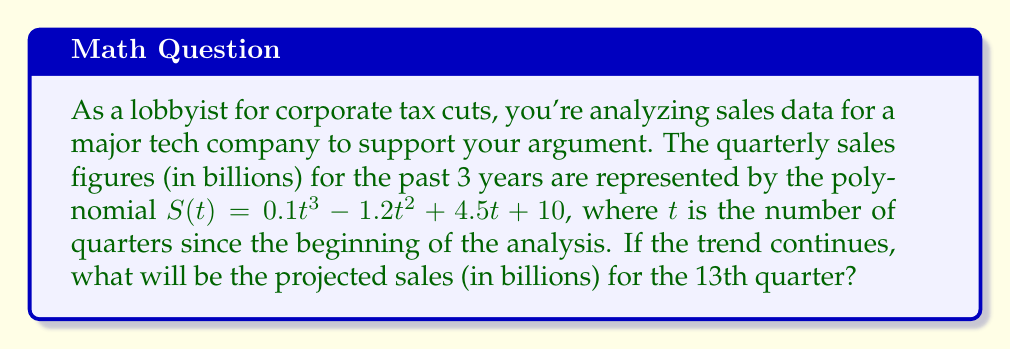Provide a solution to this math problem. To solve this problem, we need to follow these steps:

1) We're given the polynomial function for sales:
   $S(t) = 0.1t^3 - 1.2t^2 + 4.5t + 10$

2) We need to find $S(13)$, as the 13th quarter is our target.

3) Let's substitute $t = 13$ into the function:
   $S(13) = 0.1(13)^3 - 1.2(13)^2 + 4.5(13) + 10$

4) Now, let's calculate each term:
   - $0.1(13)^3 = 0.1 * 2197 = 219.7$
   - $1.2(13)^2 = 1.2 * 169 = 202.8$
   - $4.5(13) = 58.5$
   - The constant term is 10

5) Now, we can perform the final calculation:
   $S(13) = 219.7 - 202.8 + 58.5 + 10 = 85.4$

Therefore, the projected sales for the 13th quarter will be $85.4 billion.
Answer: $85.4 billion 